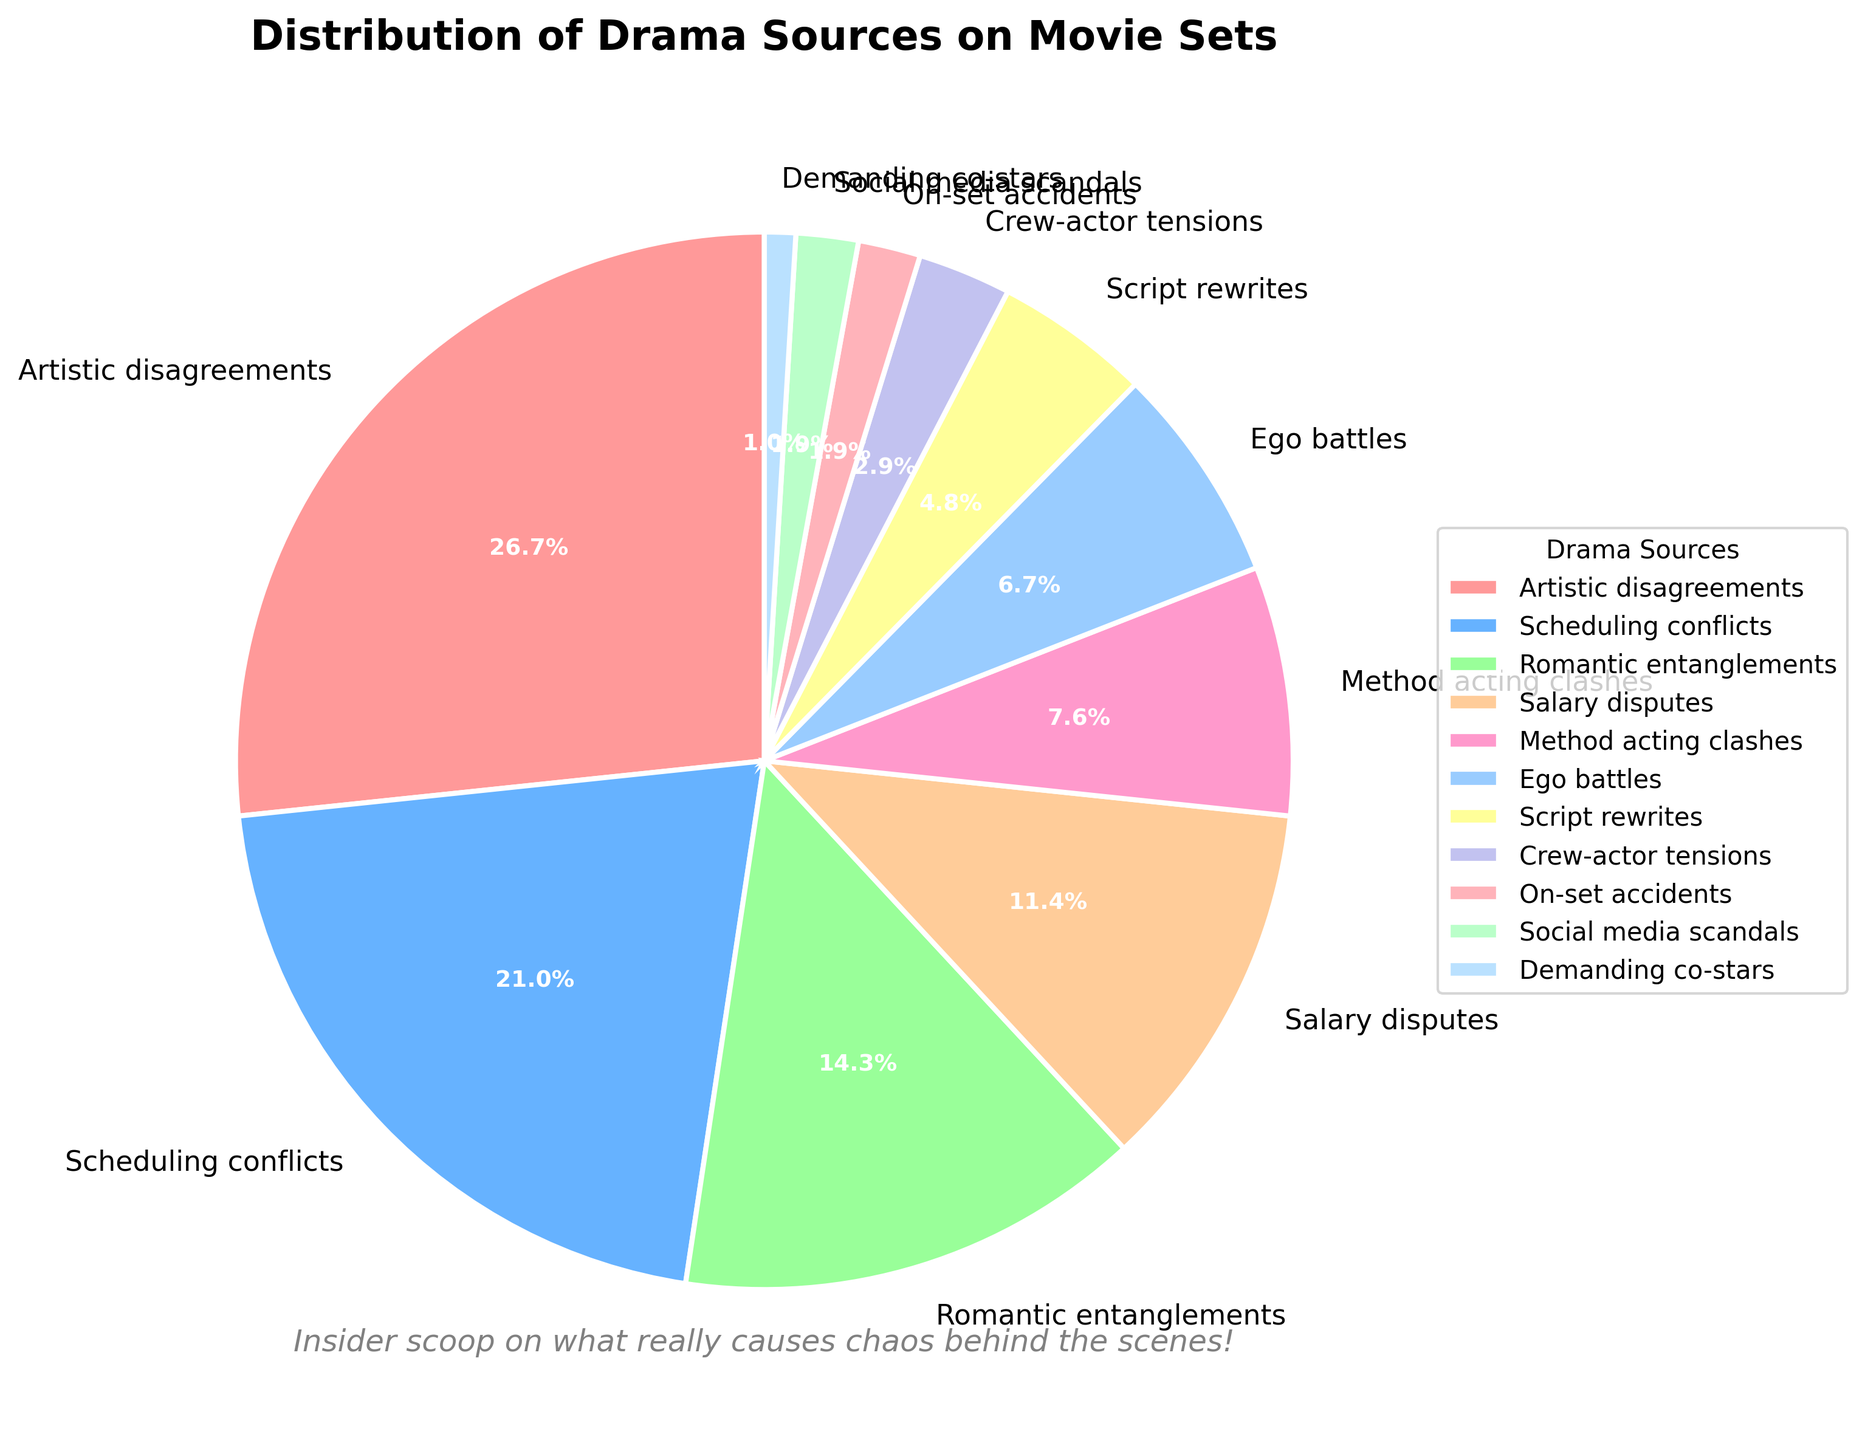What's the largest source of drama on movie sets? The pie chart shows that the largest slice represents "Artistic disagreements" with a percentage of 28%.
Answer: Artistic disagreements Which source of drama has a smaller percentage, Salary disputes or Method acting clashes? The chart shows Salary disputes at 12% and Method acting clashes at 8%. Since 8% is smaller than 12%, Method acting clashes have a smaller percentage.
Answer: Method acting clashes What is the combined percentage of Scheduling conflicts and Romantic entanglements? According to the pie chart, Scheduling conflicts are 22% and Romantic entanglements are 15%. Combined, 22% + 15% equals 37%.
Answer: 37% How many sources of drama have a percentage of 5% or lower? From the chart, the sources with 5% or lower are Script rewrites (5%), Crew-actor tensions (3%), On-set accidents (2%), Social media scandals (2%), and Demanding co-stars (1%). This adds up to 5 categories.
Answer: 5 Which sources of drama have the same percentage? The pie chart indicates that both On-set accidents and Social media scandals have a percentage of 2%.
Answer: On-set accidents and Social media scandals What's the difference in percentage between Ego battles and Method acting clashes? The chart shows Ego battles with 7% and Method acting clashes with 8%. The difference is 8% - 7% = 1%.
Answer: 1% What percentage is covered by the smallest three sources of drama? The three smallest sources are Demanding co-stars (1%), Social media scandals (2%), and On-set accidents (2%). Combined, 1% + 2% + 2% equals 5%.
Answer: 5% What are the sources with percentages greater than 10% but less than 20%? The sources in the 10%-20% range are Romantic entanglements (15%) and Salary disputes (12%).
Answer: Romantic entanglements and Salary disputes Which segment is represented by the color green? By examining the chart, the green-colored segment corresponds to "Romantic entanglements."
Answer: Romantic entanglements Between Artistic disagreements and Scheduling conflicts, which one visually appears larger? The pie chart clearly shows that Artistic disagreements, represented as 28%, takes up a larger portion than Scheduling conflicts, which is 22%.
Answer: Artistic disagreements 